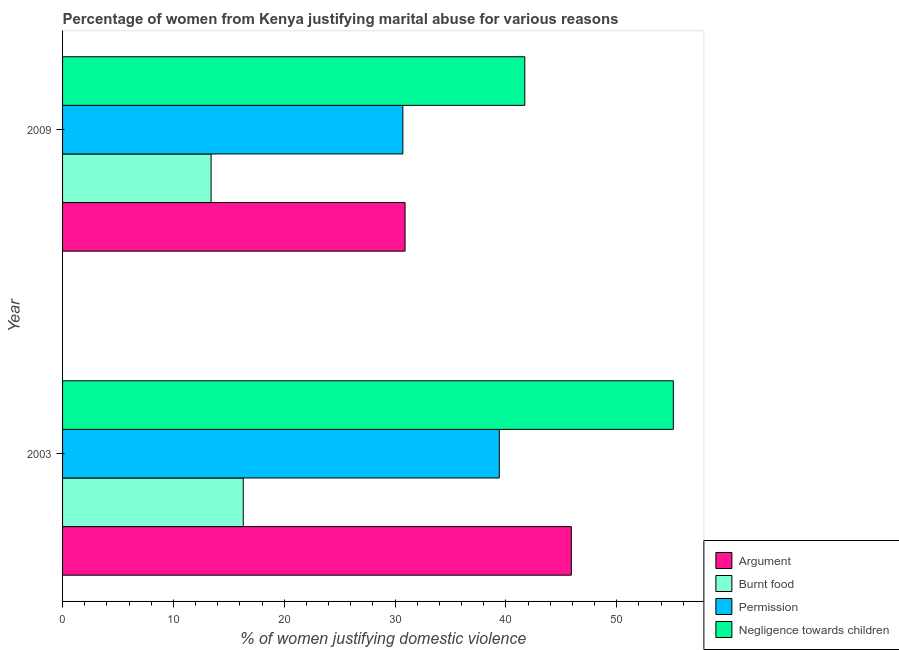How many different coloured bars are there?
Your response must be concise. 4. How many bars are there on the 1st tick from the top?
Your response must be concise. 4. How many bars are there on the 1st tick from the bottom?
Provide a succinct answer. 4. What is the percentage of women justifying abuse for going without permission in 2009?
Offer a terse response. 30.7. Across all years, what is the maximum percentage of women justifying abuse in the case of an argument?
Offer a very short reply. 45.9. What is the total percentage of women justifying abuse in the case of an argument in the graph?
Provide a short and direct response. 76.8. What is the difference between the percentage of women justifying abuse for burning food in 2003 and that in 2009?
Your response must be concise. 2.9. What is the difference between the percentage of women justifying abuse for showing negligence towards children in 2003 and the percentage of women justifying abuse for going without permission in 2009?
Ensure brevity in your answer.  24.4. What is the average percentage of women justifying abuse for showing negligence towards children per year?
Keep it short and to the point. 48.4. In the year 2009, what is the difference between the percentage of women justifying abuse for showing negligence towards children and percentage of women justifying abuse for going without permission?
Ensure brevity in your answer.  11. In how many years, is the percentage of women justifying abuse for showing negligence towards children greater than 16 %?
Provide a succinct answer. 2. What is the ratio of the percentage of women justifying abuse in the case of an argument in 2003 to that in 2009?
Ensure brevity in your answer.  1.49. Is the percentage of women justifying abuse for going without permission in 2003 less than that in 2009?
Ensure brevity in your answer.  No. Is it the case that in every year, the sum of the percentage of women justifying abuse for showing negligence towards children and percentage of women justifying abuse in the case of an argument is greater than the sum of percentage of women justifying abuse for burning food and percentage of women justifying abuse for going without permission?
Provide a succinct answer. Yes. What does the 4th bar from the top in 2003 represents?
Ensure brevity in your answer.  Argument. What does the 4th bar from the bottom in 2009 represents?
Your answer should be compact. Negligence towards children. How many bars are there?
Provide a short and direct response. 8. Are all the bars in the graph horizontal?
Make the answer very short. Yes. How many years are there in the graph?
Offer a very short reply. 2. What is the difference between two consecutive major ticks on the X-axis?
Your response must be concise. 10. Are the values on the major ticks of X-axis written in scientific E-notation?
Ensure brevity in your answer.  No. Does the graph contain any zero values?
Keep it short and to the point. No. Does the graph contain grids?
Provide a short and direct response. No. Where does the legend appear in the graph?
Give a very brief answer. Bottom right. What is the title of the graph?
Give a very brief answer. Percentage of women from Kenya justifying marital abuse for various reasons. Does "Subsidies and Transfers" appear as one of the legend labels in the graph?
Your response must be concise. No. What is the label or title of the X-axis?
Provide a short and direct response. % of women justifying domestic violence. What is the % of women justifying domestic violence of Argument in 2003?
Provide a short and direct response. 45.9. What is the % of women justifying domestic violence in Permission in 2003?
Provide a succinct answer. 39.4. What is the % of women justifying domestic violence in Negligence towards children in 2003?
Offer a very short reply. 55.1. What is the % of women justifying domestic violence in Argument in 2009?
Ensure brevity in your answer.  30.9. What is the % of women justifying domestic violence in Permission in 2009?
Offer a terse response. 30.7. What is the % of women justifying domestic violence in Negligence towards children in 2009?
Make the answer very short. 41.7. Across all years, what is the maximum % of women justifying domestic violence in Argument?
Give a very brief answer. 45.9. Across all years, what is the maximum % of women justifying domestic violence of Permission?
Offer a terse response. 39.4. Across all years, what is the maximum % of women justifying domestic violence of Negligence towards children?
Your response must be concise. 55.1. Across all years, what is the minimum % of women justifying domestic violence in Argument?
Make the answer very short. 30.9. Across all years, what is the minimum % of women justifying domestic violence in Burnt food?
Your answer should be compact. 13.4. Across all years, what is the minimum % of women justifying domestic violence of Permission?
Offer a very short reply. 30.7. Across all years, what is the minimum % of women justifying domestic violence in Negligence towards children?
Keep it short and to the point. 41.7. What is the total % of women justifying domestic violence in Argument in the graph?
Ensure brevity in your answer.  76.8. What is the total % of women justifying domestic violence in Burnt food in the graph?
Give a very brief answer. 29.7. What is the total % of women justifying domestic violence in Permission in the graph?
Give a very brief answer. 70.1. What is the total % of women justifying domestic violence of Negligence towards children in the graph?
Provide a short and direct response. 96.8. What is the difference between the % of women justifying domestic violence in Argument in 2003 and the % of women justifying domestic violence in Burnt food in 2009?
Provide a short and direct response. 32.5. What is the difference between the % of women justifying domestic violence in Argument in 2003 and the % of women justifying domestic violence in Permission in 2009?
Give a very brief answer. 15.2. What is the difference between the % of women justifying domestic violence in Burnt food in 2003 and the % of women justifying domestic violence in Permission in 2009?
Offer a terse response. -14.4. What is the difference between the % of women justifying domestic violence of Burnt food in 2003 and the % of women justifying domestic violence of Negligence towards children in 2009?
Your response must be concise. -25.4. What is the average % of women justifying domestic violence of Argument per year?
Offer a very short reply. 38.4. What is the average % of women justifying domestic violence of Burnt food per year?
Provide a succinct answer. 14.85. What is the average % of women justifying domestic violence in Permission per year?
Provide a succinct answer. 35.05. What is the average % of women justifying domestic violence of Negligence towards children per year?
Offer a terse response. 48.4. In the year 2003, what is the difference between the % of women justifying domestic violence of Argument and % of women justifying domestic violence of Burnt food?
Provide a short and direct response. 29.6. In the year 2003, what is the difference between the % of women justifying domestic violence of Argument and % of women justifying domestic violence of Negligence towards children?
Your answer should be very brief. -9.2. In the year 2003, what is the difference between the % of women justifying domestic violence in Burnt food and % of women justifying domestic violence in Permission?
Offer a terse response. -23.1. In the year 2003, what is the difference between the % of women justifying domestic violence in Burnt food and % of women justifying domestic violence in Negligence towards children?
Keep it short and to the point. -38.8. In the year 2003, what is the difference between the % of women justifying domestic violence of Permission and % of women justifying domestic violence of Negligence towards children?
Your answer should be compact. -15.7. In the year 2009, what is the difference between the % of women justifying domestic violence of Argument and % of women justifying domestic violence of Burnt food?
Provide a short and direct response. 17.5. In the year 2009, what is the difference between the % of women justifying domestic violence in Argument and % of women justifying domestic violence in Permission?
Ensure brevity in your answer.  0.2. In the year 2009, what is the difference between the % of women justifying domestic violence in Argument and % of women justifying domestic violence in Negligence towards children?
Offer a terse response. -10.8. In the year 2009, what is the difference between the % of women justifying domestic violence of Burnt food and % of women justifying domestic violence of Permission?
Offer a very short reply. -17.3. In the year 2009, what is the difference between the % of women justifying domestic violence in Burnt food and % of women justifying domestic violence in Negligence towards children?
Offer a terse response. -28.3. In the year 2009, what is the difference between the % of women justifying domestic violence in Permission and % of women justifying domestic violence in Negligence towards children?
Make the answer very short. -11. What is the ratio of the % of women justifying domestic violence in Argument in 2003 to that in 2009?
Make the answer very short. 1.49. What is the ratio of the % of women justifying domestic violence in Burnt food in 2003 to that in 2009?
Your answer should be very brief. 1.22. What is the ratio of the % of women justifying domestic violence in Permission in 2003 to that in 2009?
Keep it short and to the point. 1.28. What is the ratio of the % of women justifying domestic violence of Negligence towards children in 2003 to that in 2009?
Your answer should be very brief. 1.32. What is the difference between the highest and the second highest % of women justifying domestic violence in Burnt food?
Give a very brief answer. 2.9. What is the difference between the highest and the second highest % of women justifying domestic violence in Negligence towards children?
Offer a terse response. 13.4. What is the difference between the highest and the lowest % of women justifying domestic violence of Negligence towards children?
Provide a succinct answer. 13.4. 